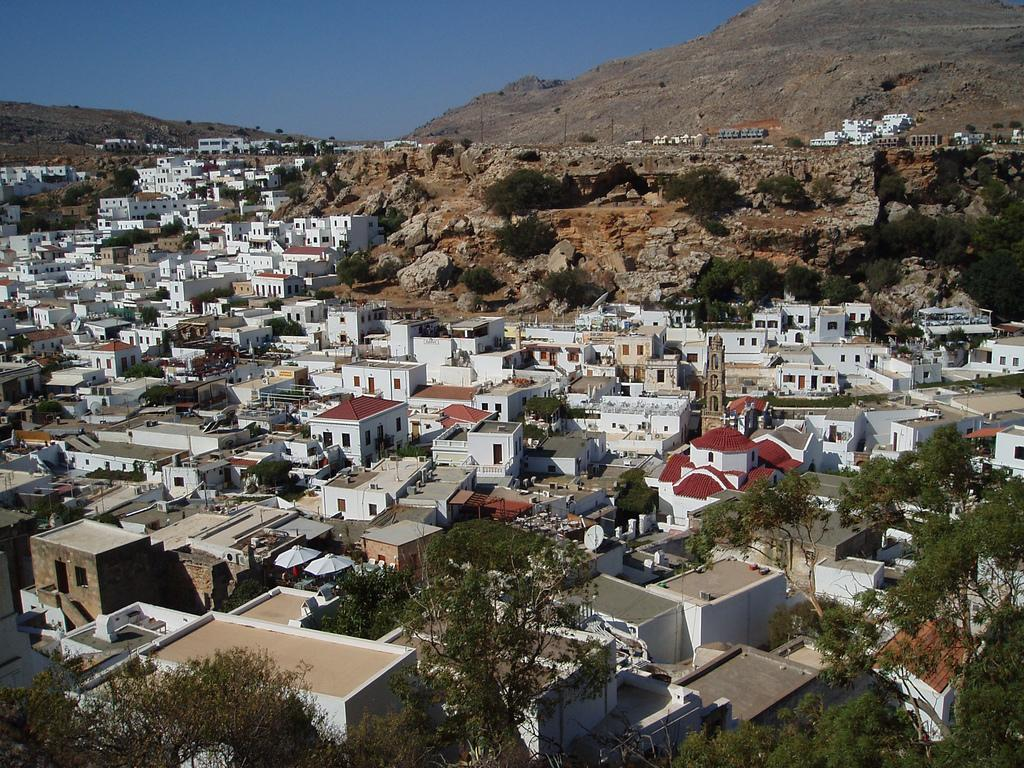What type of view is shown in the image? The image is an outside view. What can be seen in the image besides the natural environment? There are many buildings in the image. What type of vegetation is present on the ground in the image? There are trees on the ground in the image. What geographical feature is visible in the background of the image? There is a hill in the background of the image. What other objects can be seen in the background of the image? There are rocks in the background of the image. What is visible at the top of the image? The sky is visible at the top of the image. What type of bean is growing on the hill in the image? There is no bean growing on the hill in the image; it is a geographical feature with rocks visible in the background. What type of corn can be seen in the image? There is no corn present in the image. 